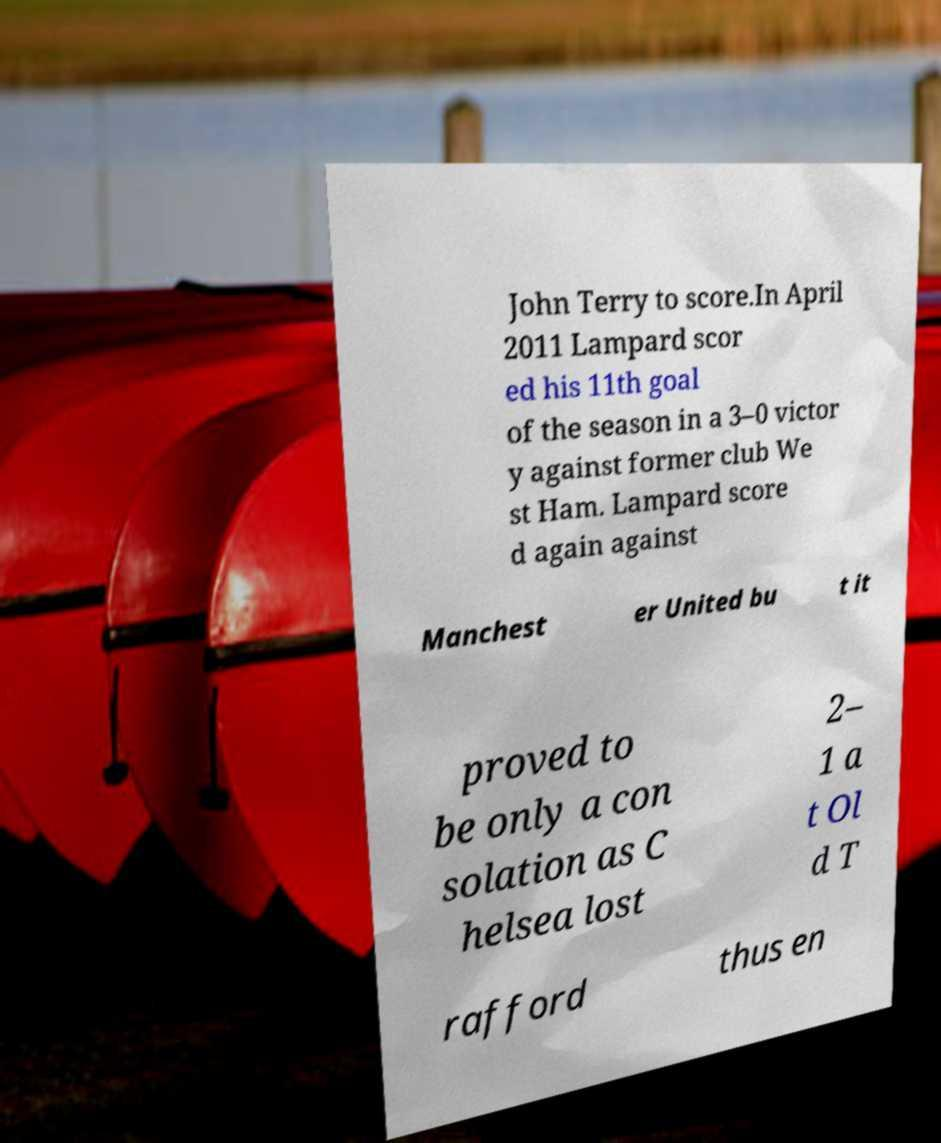Can you read and provide the text displayed in the image?This photo seems to have some interesting text. Can you extract and type it out for me? John Terry to score.In April 2011 Lampard scor ed his 11th goal of the season in a 3–0 victor y against former club We st Ham. Lampard score d again against Manchest er United bu t it proved to be only a con solation as C helsea lost 2– 1 a t Ol d T rafford thus en 